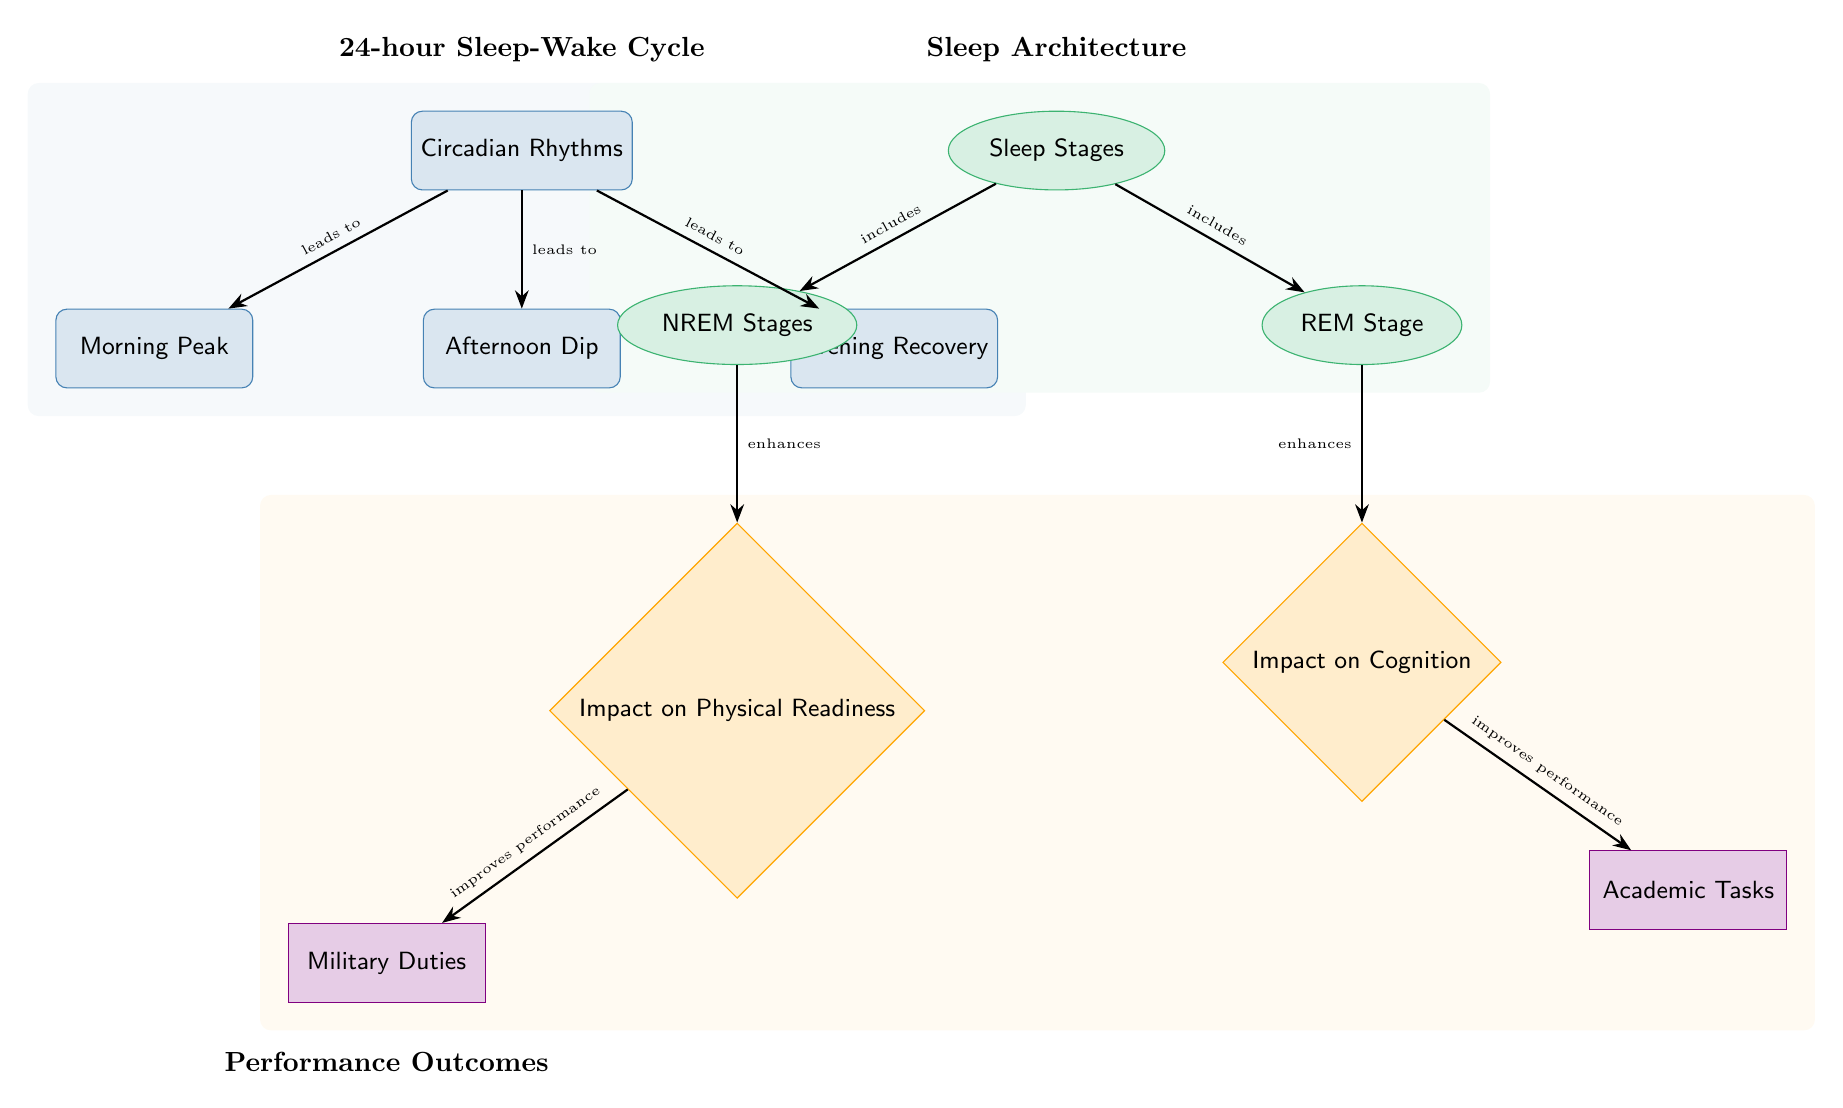What leads to the Morning Peak in Circadian Rhythms? The diagram shows that the Circadian Rhythms lead to the Morning Peak, indicated by the arrow pointing from the Circadian Rhythms node to the Morning Peak node.
Answer: leads to How many sleep stages are represented in the diagram? The diagram includes two sleep stages: NREM Stages and REM Stage, which can be counted in the Sleep Stages section of the diagram.
Answer: 2 Which stage enhances Impact on Cognition? According to the diagram, the REM Stage is connected to the Impact on Cognition, implying that it enhances cognition as suggested by the arrow pointing towards it.
Answer: REM Stage What type of tasks does the Impact on Physical Readiness improve? The diagram indicates that the Impact on Physical Readiness improves Military Duties, as shown by the arrow leading from the Impact on Physical Readiness node to the Military Duties node.
Answer: Military Duties What is included in the Sleep Stages node? The diagram specifies that the Sleep Stages node includes both NREM Stages and REM Stage, as indicated by the arrows pointing from Sleep Stages to each of these nodes.
Answer: NREM Stages and REM Stage What effect do Circadian Rhythms have during the Afternoon Dip? The diagram implies that during the Afternoon Dip, the Circadian Rhythms are present but does not specify a direct impact; rather, it shows its place within the overall cycle. Thus, there is no direct effect mentioned for this particular stage.
Answer: None specified Which node is connected to both cognitive and physical readiness impacts? The diagram reveals that the NREM Stages node leads to the Impact on Physical Readiness while the REM Stage leads to the Impact on Cognition, but they are both part of the broader Sleep Stages node, connecting these impacts to sleep architecture. Therefore, the connection is made through the Sleep Stages node.
Answer: Sleep Stages What background color is used to signify Circadian Rhythms? The background color for the Circadian Rhythms segment of the diagram is a light blue, as indicated by the coloring behind the respective nodes shown in the diagram.
Answer: Light blue 